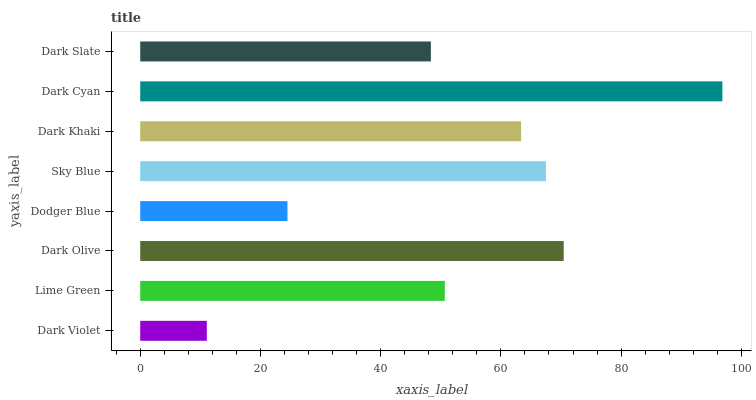Is Dark Violet the minimum?
Answer yes or no. Yes. Is Dark Cyan the maximum?
Answer yes or no. Yes. Is Lime Green the minimum?
Answer yes or no. No. Is Lime Green the maximum?
Answer yes or no. No. Is Lime Green greater than Dark Violet?
Answer yes or no. Yes. Is Dark Violet less than Lime Green?
Answer yes or no. Yes. Is Dark Violet greater than Lime Green?
Answer yes or no. No. Is Lime Green less than Dark Violet?
Answer yes or no. No. Is Dark Khaki the high median?
Answer yes or no. Yes. Is Lime Green the low median?
Answer yes or no. Yes. Is Dodger Blue the high median?
Answer yes or no. No. Is Sky Blue the low median?
Answer yes or no. No. 